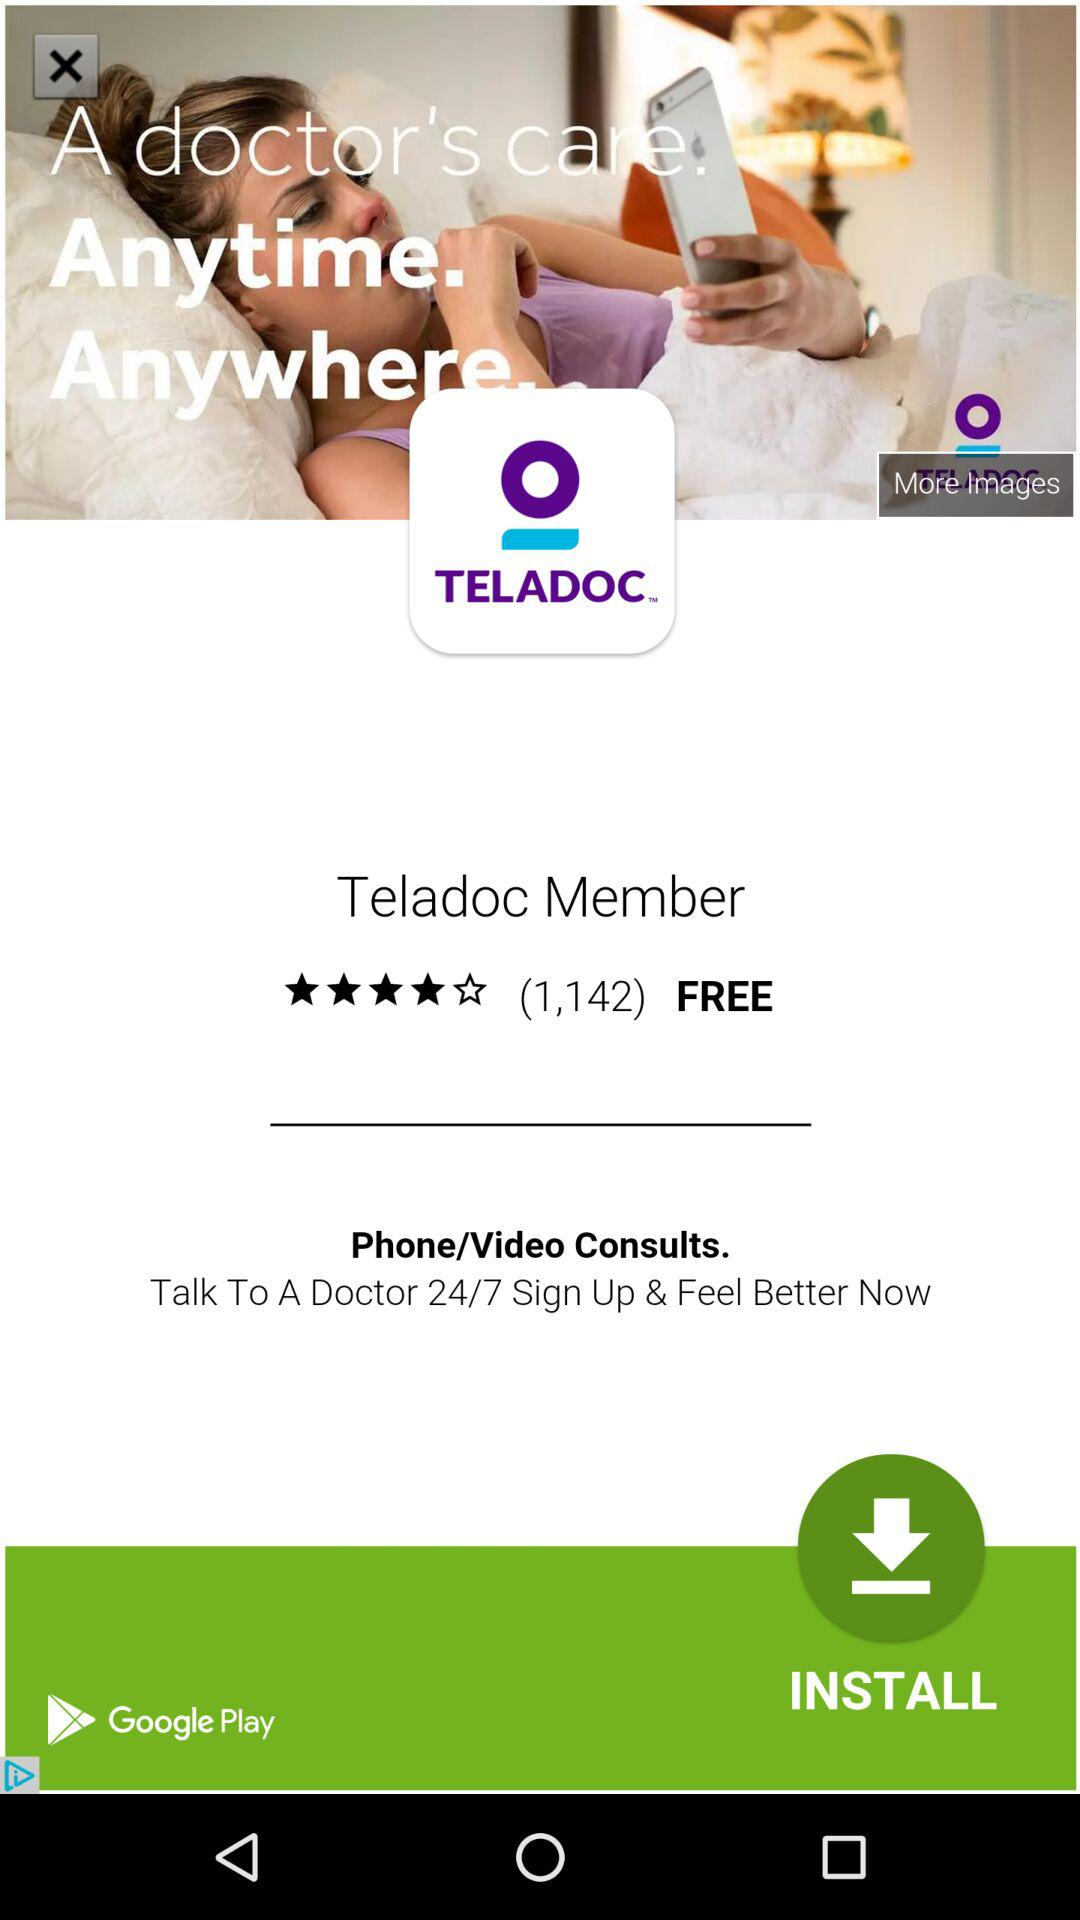What is the name of the application? The name of the application is "TELADOC". 